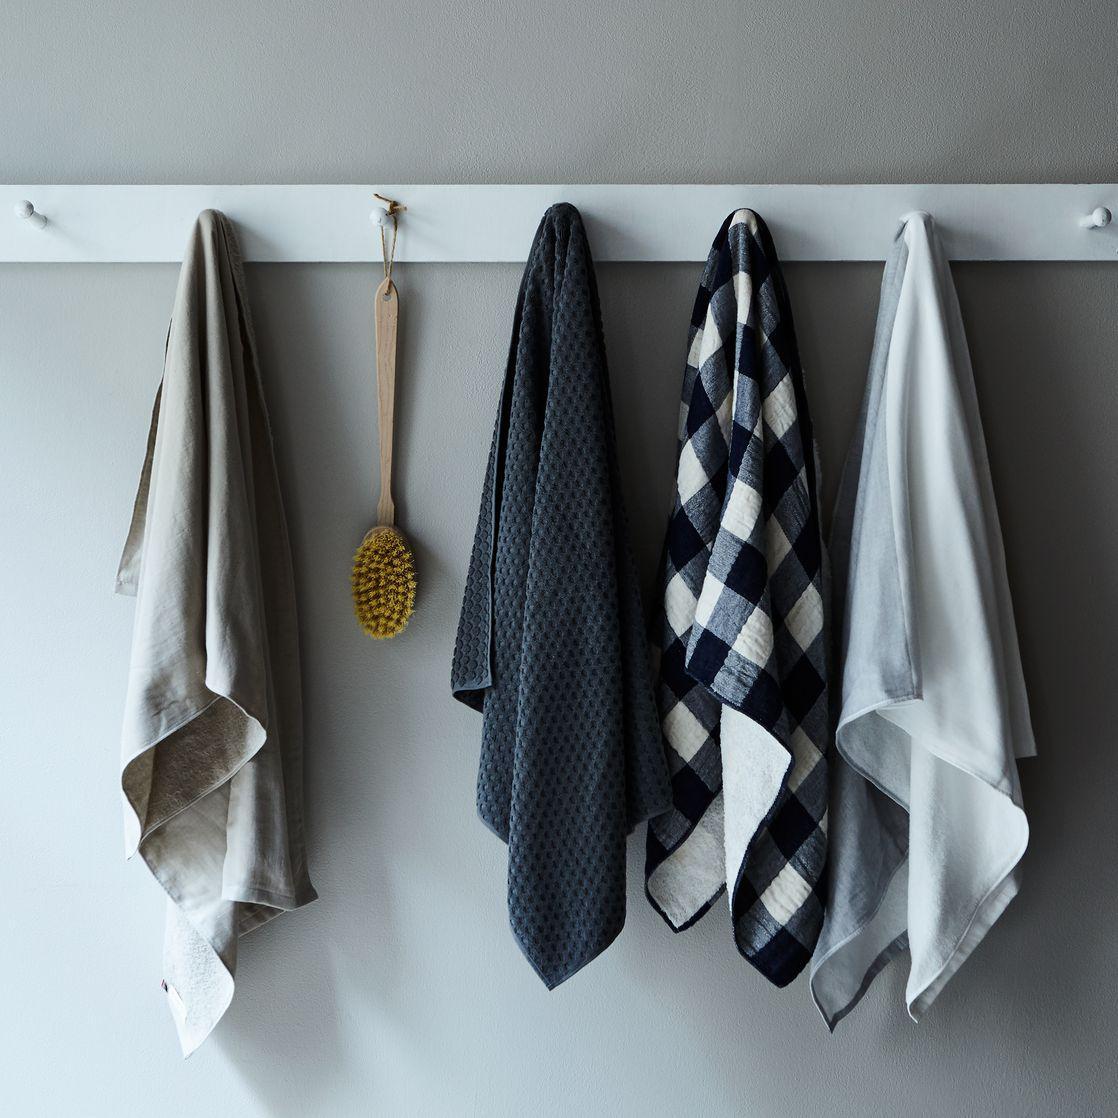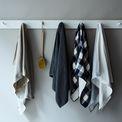The first image is the image on the left, the second image is the image on the right. Analyze the images presented: Is the assertion "An equal number of towels is hanging in each image." valid? Answer yes or no. Yes. 